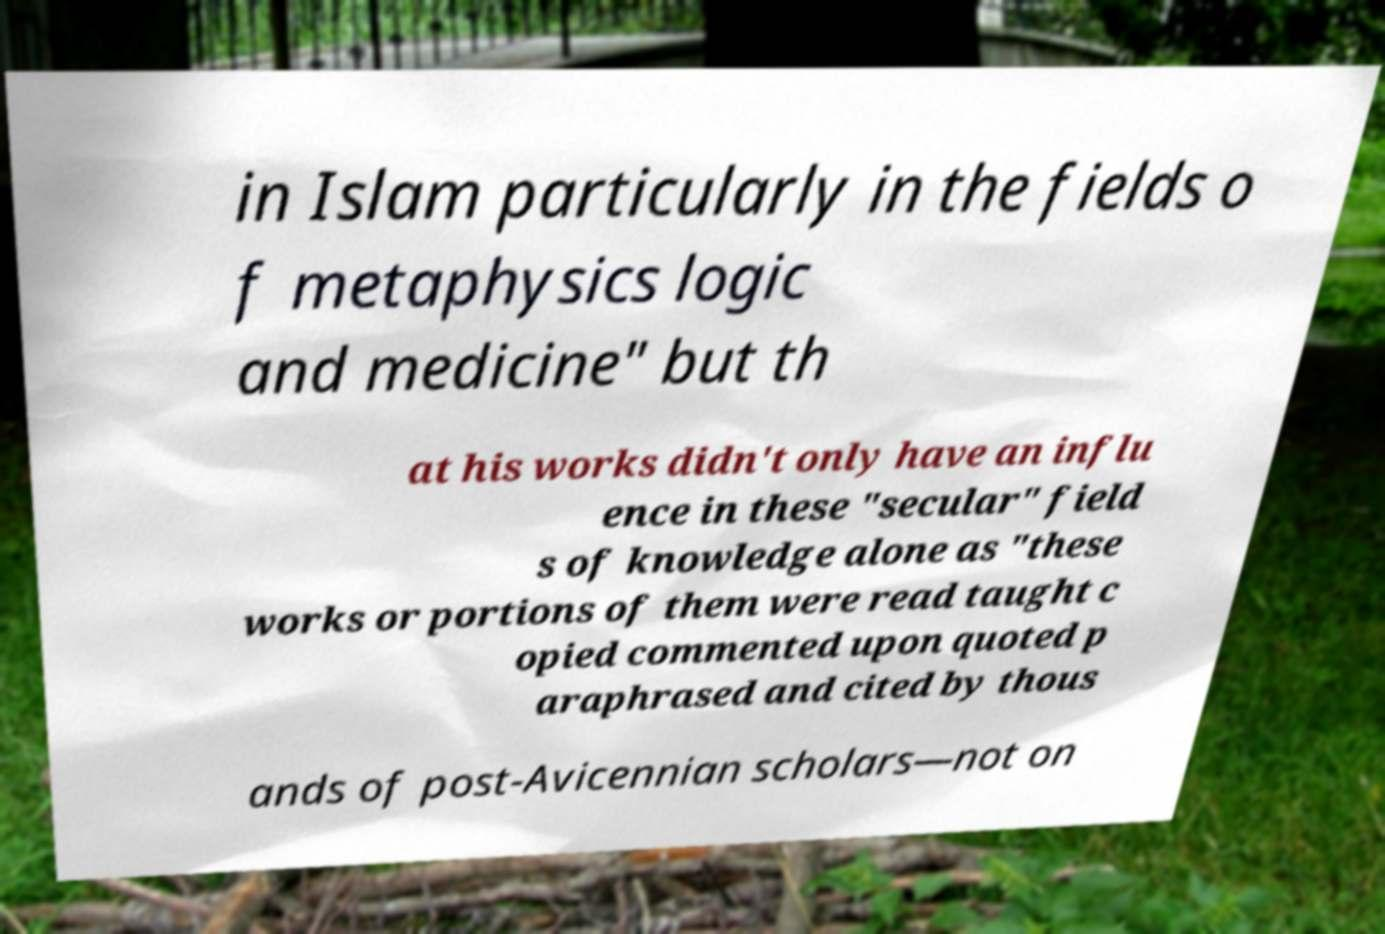Please identify and transcribe the text found in this image. in Islam particularly in the fields o f metaphysics logic and medicine" but th at his works didn't only have an influ ence in these "secular" field s of knowledge alone as "these works or portions of them were read taught c opied commented upon quoted p araphrased and cited by thous ands of post-Avicennian scholars—not on 